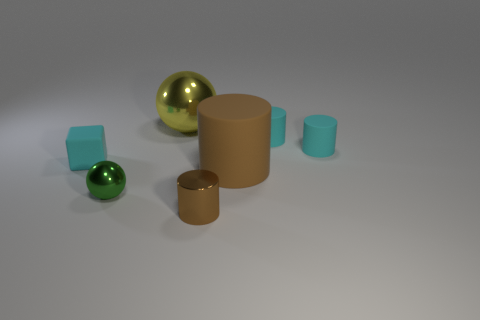Is there a large yellow sphere that is left of the sphere that is in front of the cyan thing to the left of the big brown thing?
Offer a terse response. No. What number of big objects are gray cylinders or yellow things?
Provide a succinct answer. 1. Are there any other things of the same color as the small ball?
Offer a very short reply. No. There is a metal thing that is behind the cyan rubber block; does it have the same size as the brown metallic cylinder?
Provide a short and direct response. No. There is a small matte thing to the left of the brown metallic cylinder that is left of the big thing that is in front of the small cyan rubber cube; what color is it?
Offer a terse response. Cyan. What color is the small metal cylinder?
Offer a terse response. Brown. Is the color of the shiny cylinder the same as the small metallic ball?
Offer a terse response. No. Is the material of the small cylinder that is in front of the green ball the same as the big thing to the right of the big shiny sphere?
Your answer should be very brief. No. What is the material of the tiny brown thing that is the same shape as the large brown rubber thing?
Offer a terse response. Metal. Is the material of the green object the same as the large brown object?
Make the answer very short. No. 